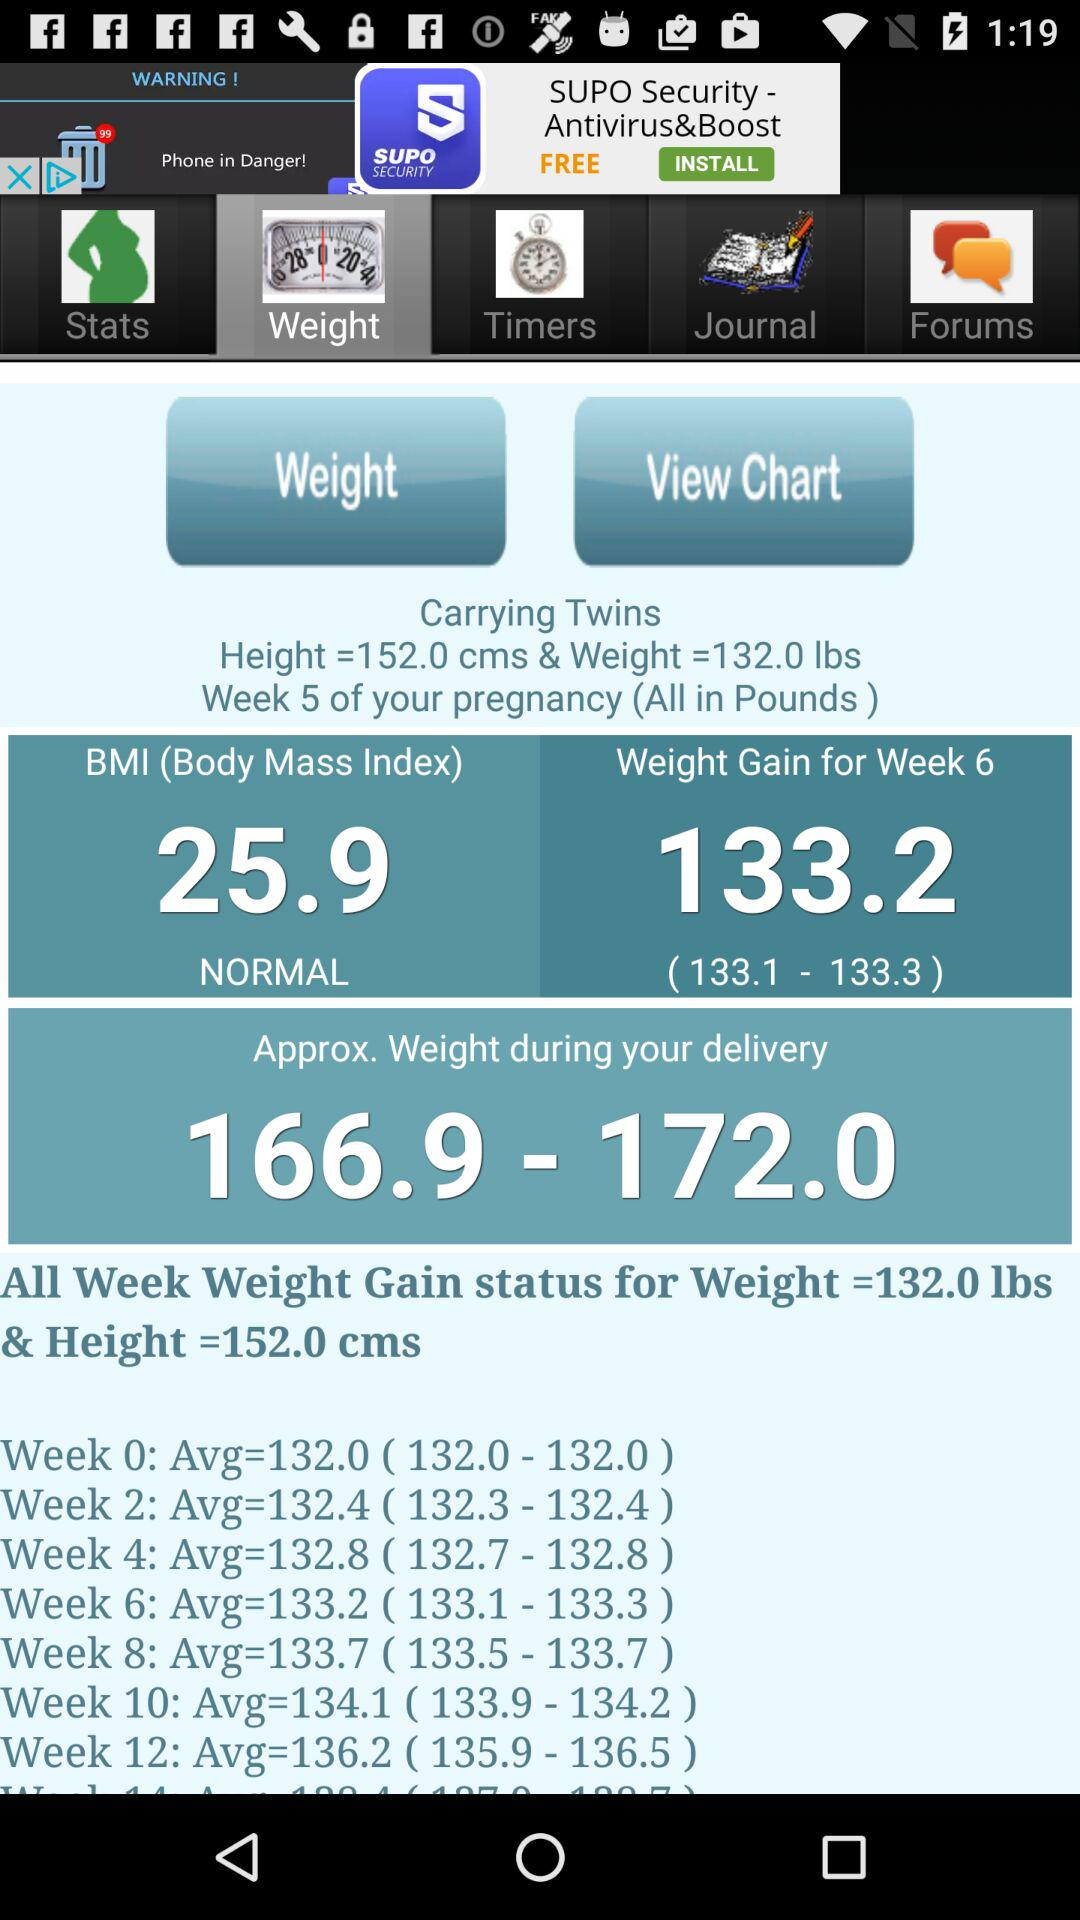What should the weight be during delivery? The weight during delivery should be between 166.9 and 172.0. 